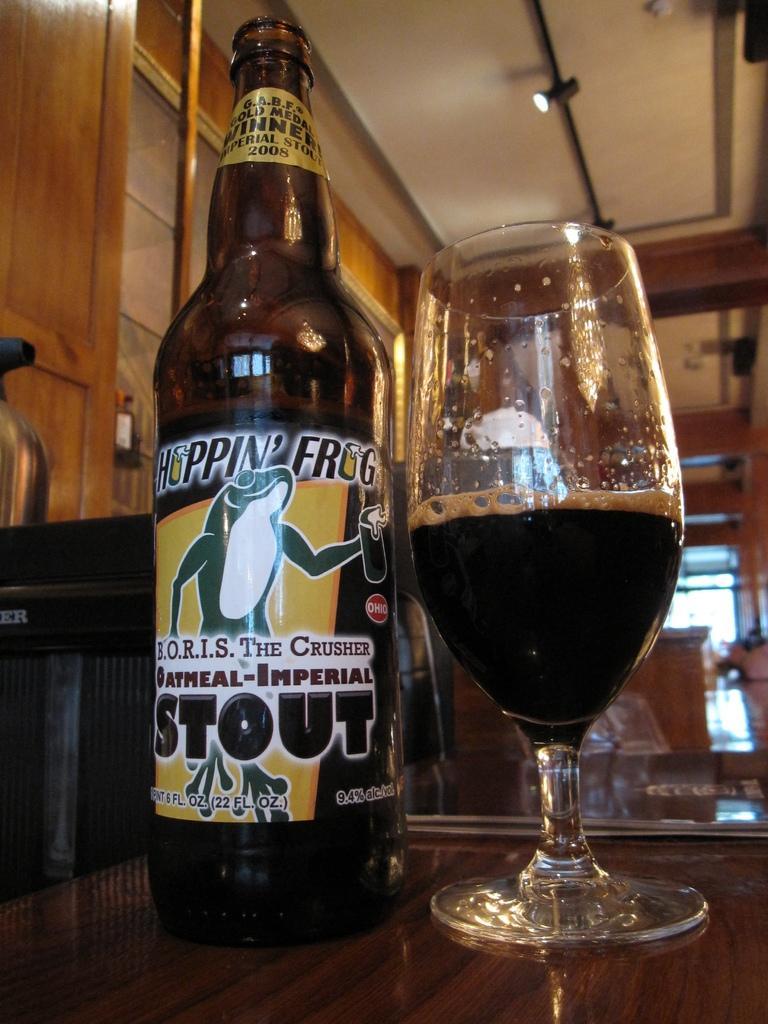How would you summarize this image in a sentence or two? This is an inside view. At the bottom there is a table on which a bottle and a wine glass are placed. In the background there are few objects and a window. On the left side there is a door and also I can see the wall. At the top of the image there is a light to a metal rod and also I can see the roof. 